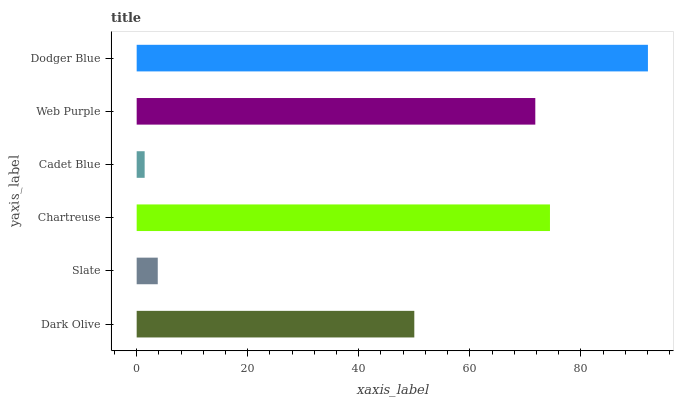Is Cadet Blue the minimum?
Answer yes or no. Yes. Is Dodger Blue the maximum?
Answer yes or no. Yes. Is Slate the minimum?
Answer yes or no. No. Is Slate the maximum?
Answer yes or no. No. Is Dark Olive greater than Slate?
Answer yes or no. Yes. Is Slate less than Dark Olive?
Answer yes or no. Yes. Is Slate greater than Dark Olive?
Answer yes or no. No. Is Dark Olive less than Slate?
Answer yes or no. No. Is Web Purple the high median?
Answer yes or no. Yes. Is Dark Olive the low median?
Answer yes or no. Yes. Is Cadet Blue the high median?
Answer yes or no. No. Is Dodger Blue the low median?
Answer yes or no. No. 